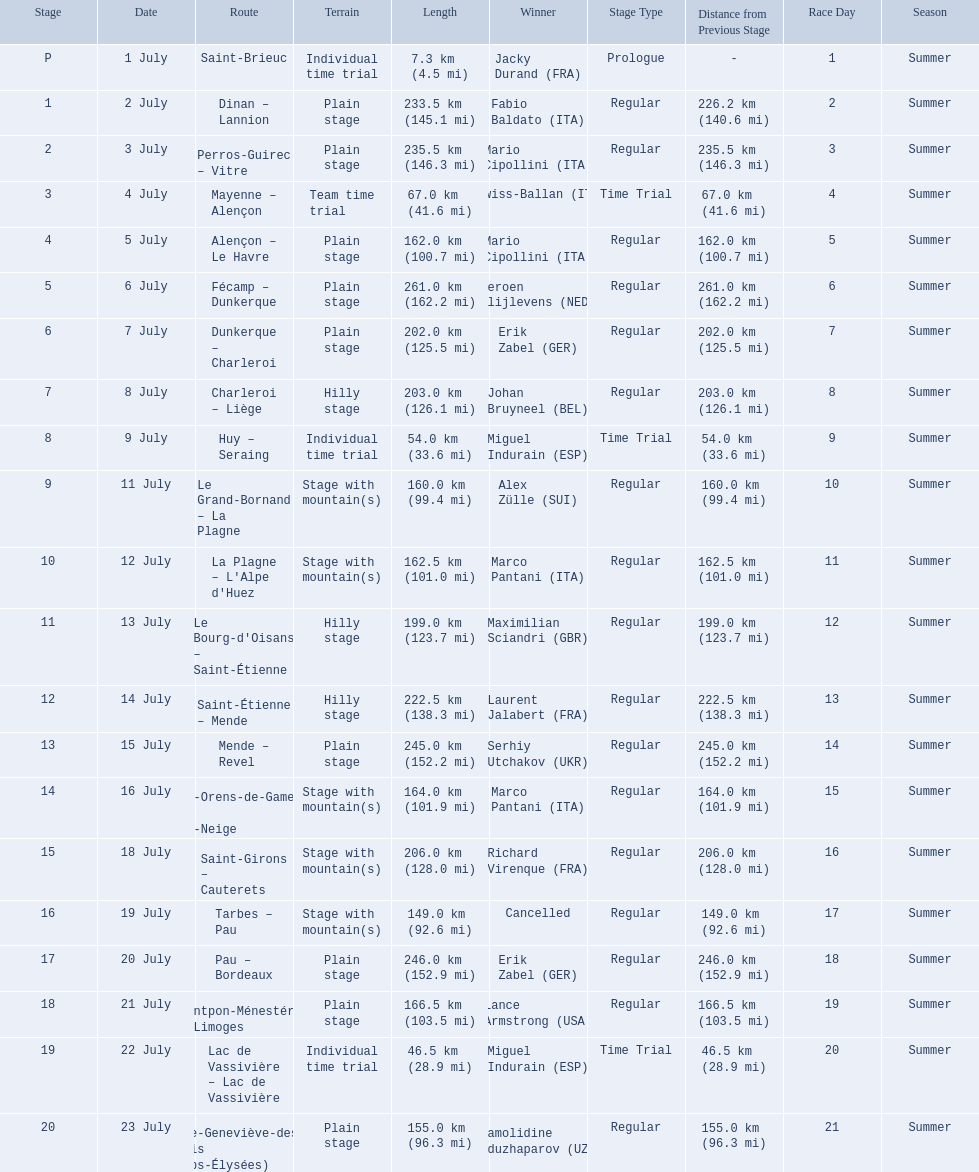What are the dates? 1 July, 2 July, 3 July, 4 July, 5 July, 6 July, 7 July, 8 July, 9 July, 11 July, 12 July, 13 July, 14 July, 15 July, 16 July, 18 July, 19 July, 20 July, 21 July, 22 July, 23 July. What is the length on 8 july? 203.0 km (126.1 mi). 